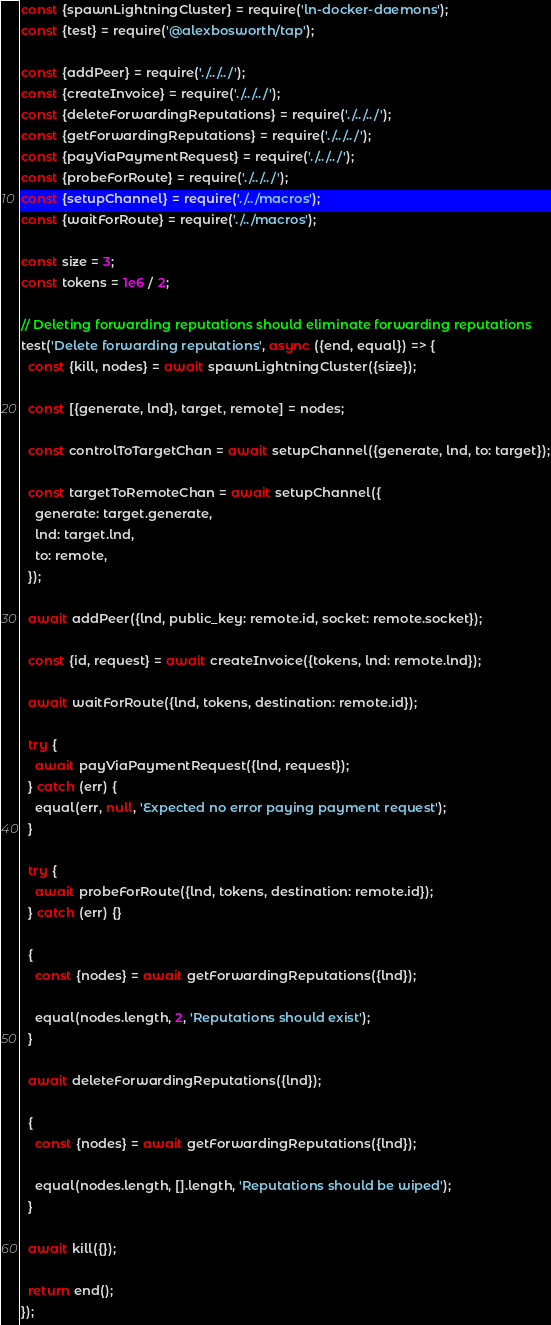Convert code to text. <code><loc_0><loc_0><loc_500><loc_500><_JavaScript_>const {spawnLightningCluster} = require('ln-docker-daemons');
const {test} = require('@alexbosworth/tap');

const {addPeer} = require('./../../');
const {createInvoice} = require('./../../');
const {deleteForwardingReputations} = require('./../../');
const {getForwardingReputations} = require('./../../');
const {payViaPaymentRequest} = require('./../../');
const {probeForRoute} = require('./../../');
const {setupChannel} = require('./../macros');
const {waitForRoute} = require('./../macros');

const size = 3;
const tokens = 1e6 / 2;

// Deleting forwarding reputations should eliminate forwarding reputations
test('Delete forwarding reputations', async ({end, equal}) => {
  const {kill, nodes} = await spawnLightningCluster({size});

  const [{generate, lnd}, target, remote] = nodes;

  const controlToTargetChan = await setupChannel({generate, lnd, to: target});

  const targetToRemoteChan = await setupChannel({
    generate: target.generate,
    lnd: target.lnd,
    to: remote,
  });

  await addPeer({lnd, public_key: remote.id, socket: remote.socket});

  const {id, request} = await createInvoice({tokens, lnd: remote.lnd});

  await waitForRoute({lnd, tokens, destination: remote.id});

  try {
    await payViaPaymentRequest({lnd, request});
  } catch (err) {
    equal(err, null, 'Expected no error paying payment request');
  }

  try {
    await probeForRoute({lnd, tokens, destination: remote.id});
  } catch (err) {}

  {
    const {nodes} = await getForwardingReputations({lnd});

    equal(nodes.length, 2, 'Reputations should exist');
  }

  await deleteForwardingReputations({lnd});

  {
    const {nodes} = await getForwardingReputations({lnd});

    equal(nodes.length, [].length, 'Reputations should be wiped');
  }

  await kill({});

  return end();
});
</code> 